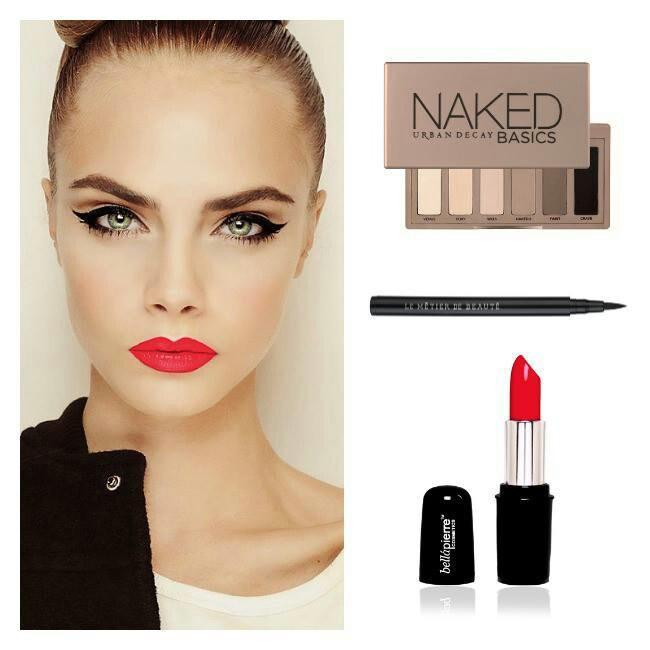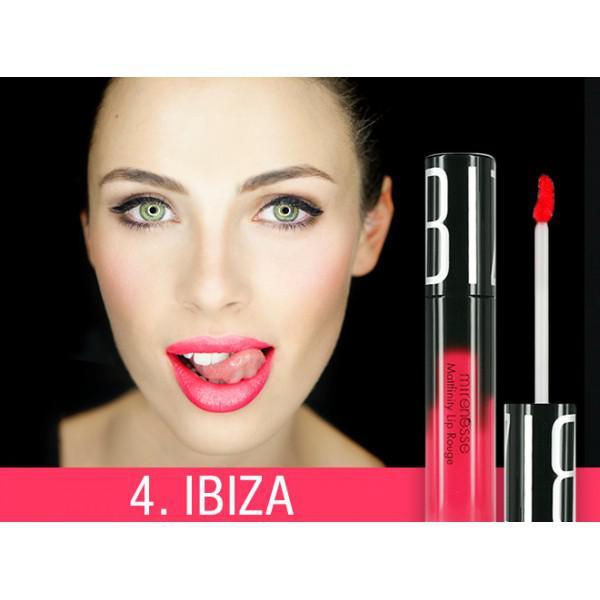The first image is the image on the left, the second image is the image on the right. Assess this claim about the two images: "There is exactly one hand visible in one of the images". Correct or not? Answer yes or no. No. The first image is the image on the left, the second image is the image on the right. Analyze the images presented: Is the assertion "Both images show models with non-pursed open mouths with no tongue showing." valid? Answer yes or no. No. 